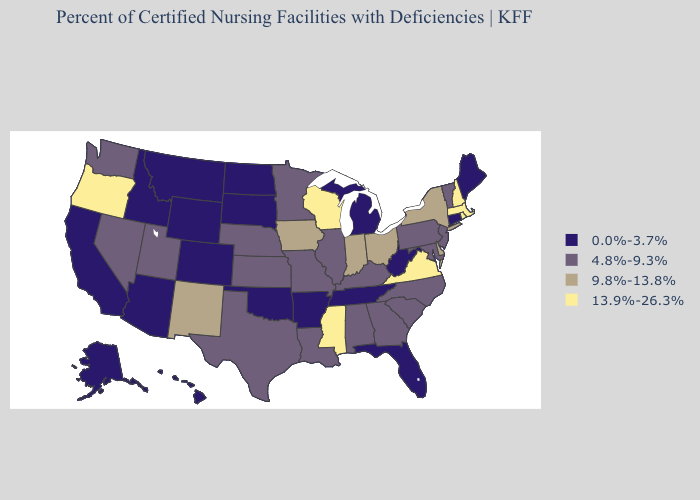Name the states that have a value in the range 9.8%-13.8%?
Write a very short answer. Delaware, Indiana, Iowa, New Mexico, New York, Ohio. What is the lowest value in states that border North Dakota?
Write a very short answer. 0.0%-3.7%. Does New Mexico have a lower value than New Hampshire?
Be succinct. Yes. Does Oregon have the highest value in the USA?
Be succinct. Yes. What is the highest value in the Northeast ?
Keep it brief. 13.9%-26.3%. Does New Mexico have the same value as Indiana?
Write a very short answer. Yes. What is the lowest value in states that border North Carolina?
Write a very short answer. 0.0%-3.7%. Name the states that have a value in the range 0.0%-3.7%?
Concise answer only. Alaska, Arizona, Arkansas, California, Colorado, Connecticut, Florida, Hawaii, Idaho, Maine, Michigan, Montana, North Dakota, Oklahoma, South Dakota, Tennessee, West Virginia, Wyoming. Does Michigan have the highest value in the USA?
Write a very short answer. No. Does Illinois have a higher value than Oklahoma?
Be succinct. Yes. What is the highest value in the USA?
Be succinct. 13.9%-26.3%. Does South Carolina have the highest value in the USA?
Be succinct. No. Name the states that have a value in the range 0.0%-3.7%?
Short answer required. Alaska, Arizona, Arkansas, California, Colorado, Connecticut, Florida, Hawaii, Idaho, Maine, Michigan, Montana, North Dakota, Oklahoma, South Dakota, Tennessee, West Virginia, Wyoming. What is the lowest value in states that border Pennsylvania?
Give a very brief answer. 0.0%-3.7%. Name the states that have a value in the range 9.8%-13.8%?
Write a very short answer. Delaware, Indiana, Iowa, New Mexico, New York, Ohio. 